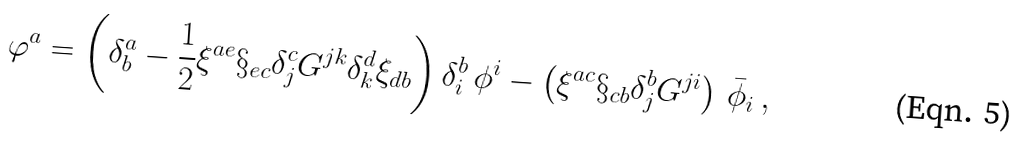Convert formula to latex. <formula><loc_0><loc_0><loc_500><loc_500>\varphi ^ { a } = \left ( \delta _ { b } ^ { a } - \frac { 1 } { 2 } \xi ^ { a e } \S _ { e c } \delta _ { j } ^ { c } G ^ { j k } \delta _ { k } ^ { d } \xi _ { d b } \right ) \delta _ { i } ^ { b } \, \phi ^ { i } - \left ( \xi ^ { a c } \S _ { c b } \delta _ { j } ^ { b } G ^ { j i } \right ) \, { \bar { \phi } } _ { i } \, ,</formula> 